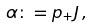<formula> <loc_0><loc_0><loc_500><loc_500>\alpha \colon = p _ { + } J \, ,</formula> 